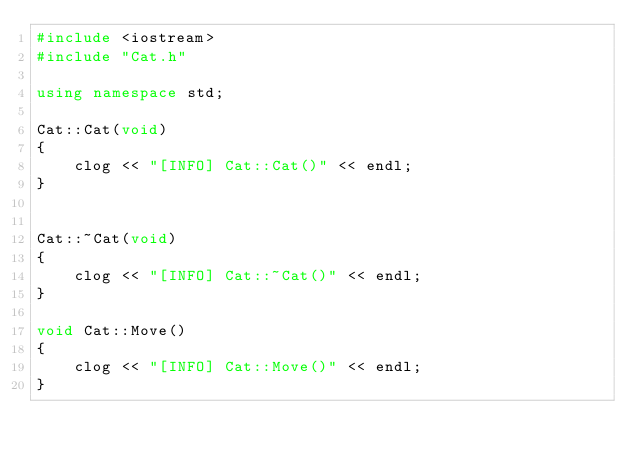Convert code to text. <code><loc_0><loc_0><loc_500><loc_500><_C++_>#include <iostream>
#include "Cat.h"

using namespace std;

Cat::Cat(void)
{
	clog << "[INFO] Cat::Cat()" << endl;
}


Cat::~Cat(void)
{
	clog << "[INFO] Cat::~Cat()" << endl;
}

void Cat::Move()
{
	clog << "[INFO] Cat::Move()" << endl;
}</code> 